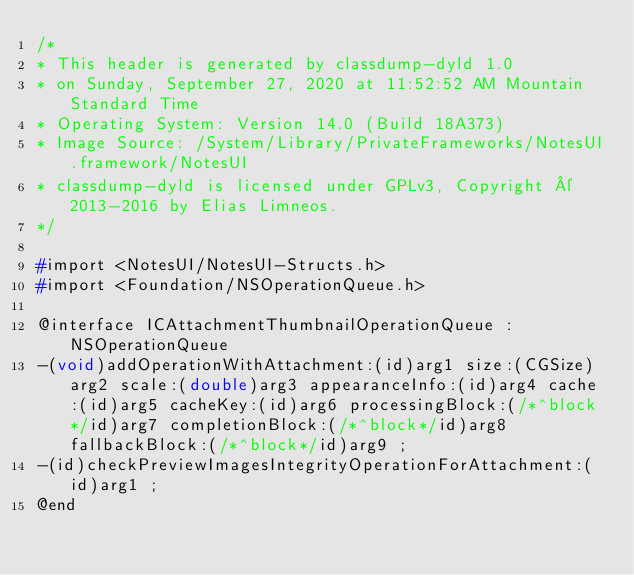<code> <loc_0><loc_0><loc_500><loc_500><_C_>/*
* This header is generated by classdump-dyld 1.0
* on Sunday, September 27, 2020 at 11:52:52 AM Mountain Standard Time
* Operating System: Version 14.0 (Build 18A373)
* Image Source: /System/Library/PrivateFrameworks/NotesUI.framework/NotesUI
* classdump-dyld is licensed under GPLv3, Copyright © 2013-2016 by Elias Limneos.
*/

#import <NotesUI/NotesUI-Structs.h>
#import <Foundation/NSOperationQueue.h>

@interface ICAttachmentThumbnailOperationQueue : NSOperationQueue
-(void)addOperationWithAttachment:(id)arg1 size:(CGSize)arg2 scale:(double)arg3 appearanceInfo:(id)arg4 cache:(id)arg5 cacheKey:(id)arg6 processingBlock:(/*^block*/id)arg7 completionBlock:(/*^block*/id)arg8 fallbackBlock:(/*^block*/id)arg9 ;
-(id)checkPreviewImagesIntegrityOperationForAttachment:(id)arg1 ;
@end

</code> 